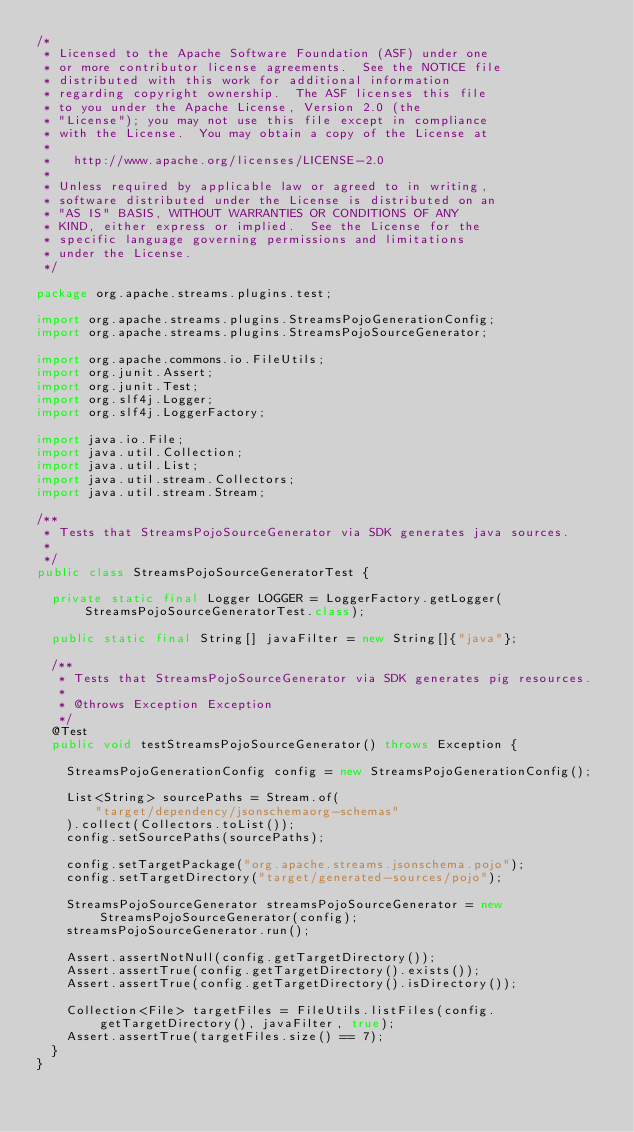Convert code to text. <code><loc_0><loc_0><loc_500><loc_500><_Java_>/*
 * Licensed to the Apache Software Foundation (ASF) under one
 * or more contributor license agreements.  See the NOTICE file
 * distributed with this work for additional information
 * regarding copyright ownership.  The ASF licenses this file
 * to you under the Apache License, Version 2.0 (the
 * "License"); you may not use this file except in compliance
 * with the License.  You may obtain a copy of the License at
 *
 *   http://www.apache.org/licenses/LICENSE-2.0
 *
 * Unless required by applicable law or agreed to in writing,
 * software distributed under the License is distributed on an
 * "AS IS" BASIS, WITHOUT WARRANTIES OR CONDITIONS OF ANY
 * KIND, either express or implied.  See the License for the
 * specific language governing permissions and limitations
 * under the License.
 */

package org.apache.streams.plugins.test;

import org.apache.streams.plugins.StreamsPojoGenerationConfig;
import org.apache.streams.plugins.StreamsPojoSourceGenerator;

import org.apache.commons.io.FileUtils;
import org.junit.Assert;
import org.junit.Test;
import org.slf4j.Logger;
import org.slf4j.LoggerFactory;

import java.io.File;
import java.util.Collection;
import java.util.List;
import java.util.stream.Collectors;
import java.util.stream.Stream;

/**
 * Tests that StreamsPojoSourceGenerator via SDK generates java sources.
 *
 */
public class StreamsPojoSourceGeneratorTest {

  private static final Logger LOGGER = LoggerFactory.getLogger(StreamsPojoSourceGeneratorTest.class);

  public static final String[] javaFilter = new String[]{"java"};

  /**
   * Tests that StreamsPojoSourceGenerator via SDK generates pig resources.
   *
   * @throws Exception Exception
   */
  @Test
  public void testStreamsPojoSourceGenerator() throws Exception {

    StreamsPojoGenerationConfig config = new StreamsPojoGenerationConfig();

    List<String> sourcePaths = Stream.of(
        "target/dependency/jsonschemaorg-schemas"
    ).collect(Collectors.toList());
    config.setSourcePaths(sourcePaths);

    config.setTargetPackage("org.apache.streams.jsonschema.pojo");
    config.setTargetDirectory("target/generated-sources/pojo");

    StreamsPojoSourceGenerator streamsPojoSourceGenerator = new StreamsPojoSourceGenerator(config);
    streamsPojoSourceGenerator.run();

    Assert.assertNotNull(config.getTargetDirectory());
    Assert.assertTrue(config.getTargetDirectory().exists());
    Assert.assertTrue(config.getTargetDirectory().isDirectory());

    Collection<File> targetFiles = FileUtils.listFiles(config.getTargetDirectory(), javaFilter, true);
    Assert.assertTrue(targetFiles.size() == 7);
  }
}</code> 